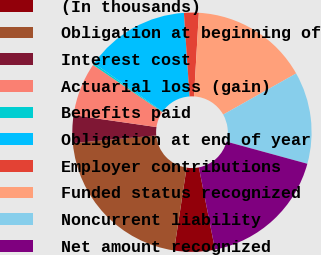Convert chart. <chart><loc_0><loc_0><loc_500><loc_500><pie_chart><fcel>(In thousands)<fcel>Obligation at beginning of<fcel>Interest cost<fcel>Actuarial loss (gain)<fcel>Benefits paid<fcel>Obligation at end of year<fcel>Employer contributions<fcel>Funded status recognized<fcel>Noncurrent liability<fcel>Net amount recognized<nl><fcel>5.48%<fcel>21.15%<fcel>3.74%<fcel>7.23%<fcel>0.25%<fcel>14.17%<fcel>1.99%<fcel>15.91%<fcel>12.42%<fcel>17.66%<nl></chart> 